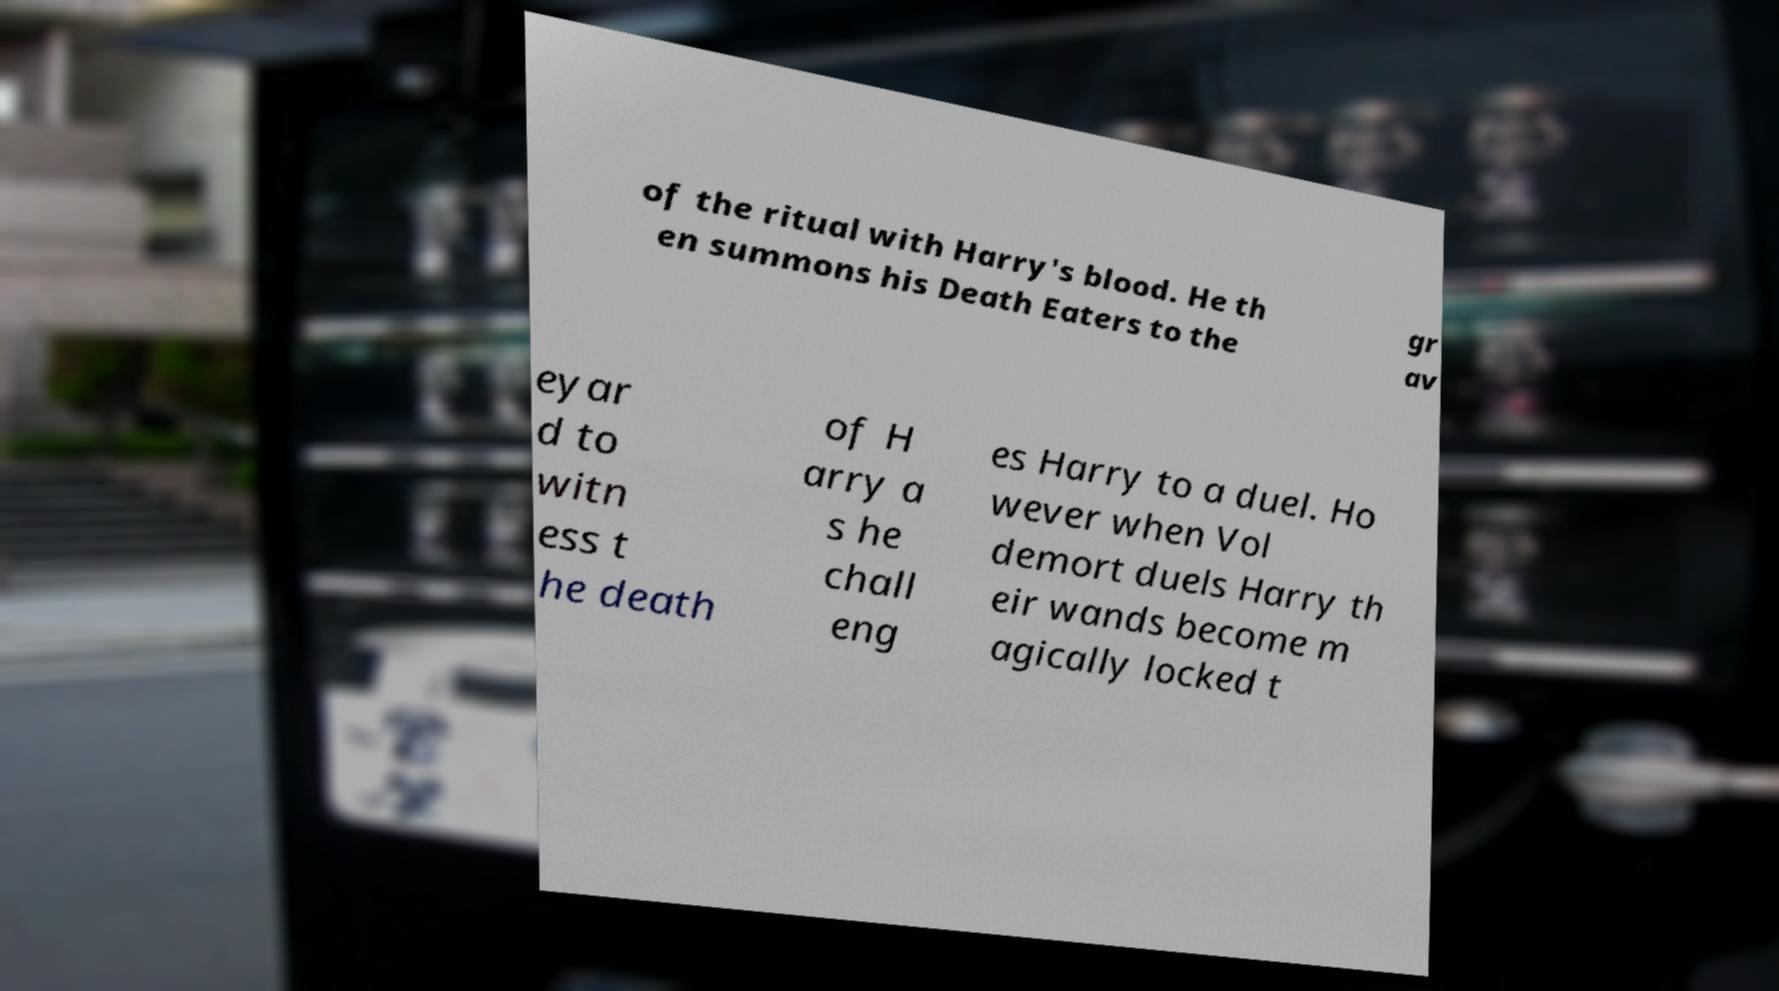I need the written content from this picture converted into text. Can you do that? of the ritual with Harry's blood. He th en summons his Death Eaters to the gr av eyar d to witn ess t he death of H arry a s he chall eng es Harry to a duel. Ho wever when Vol demort duels Harry th eir wands become m agically locked t 